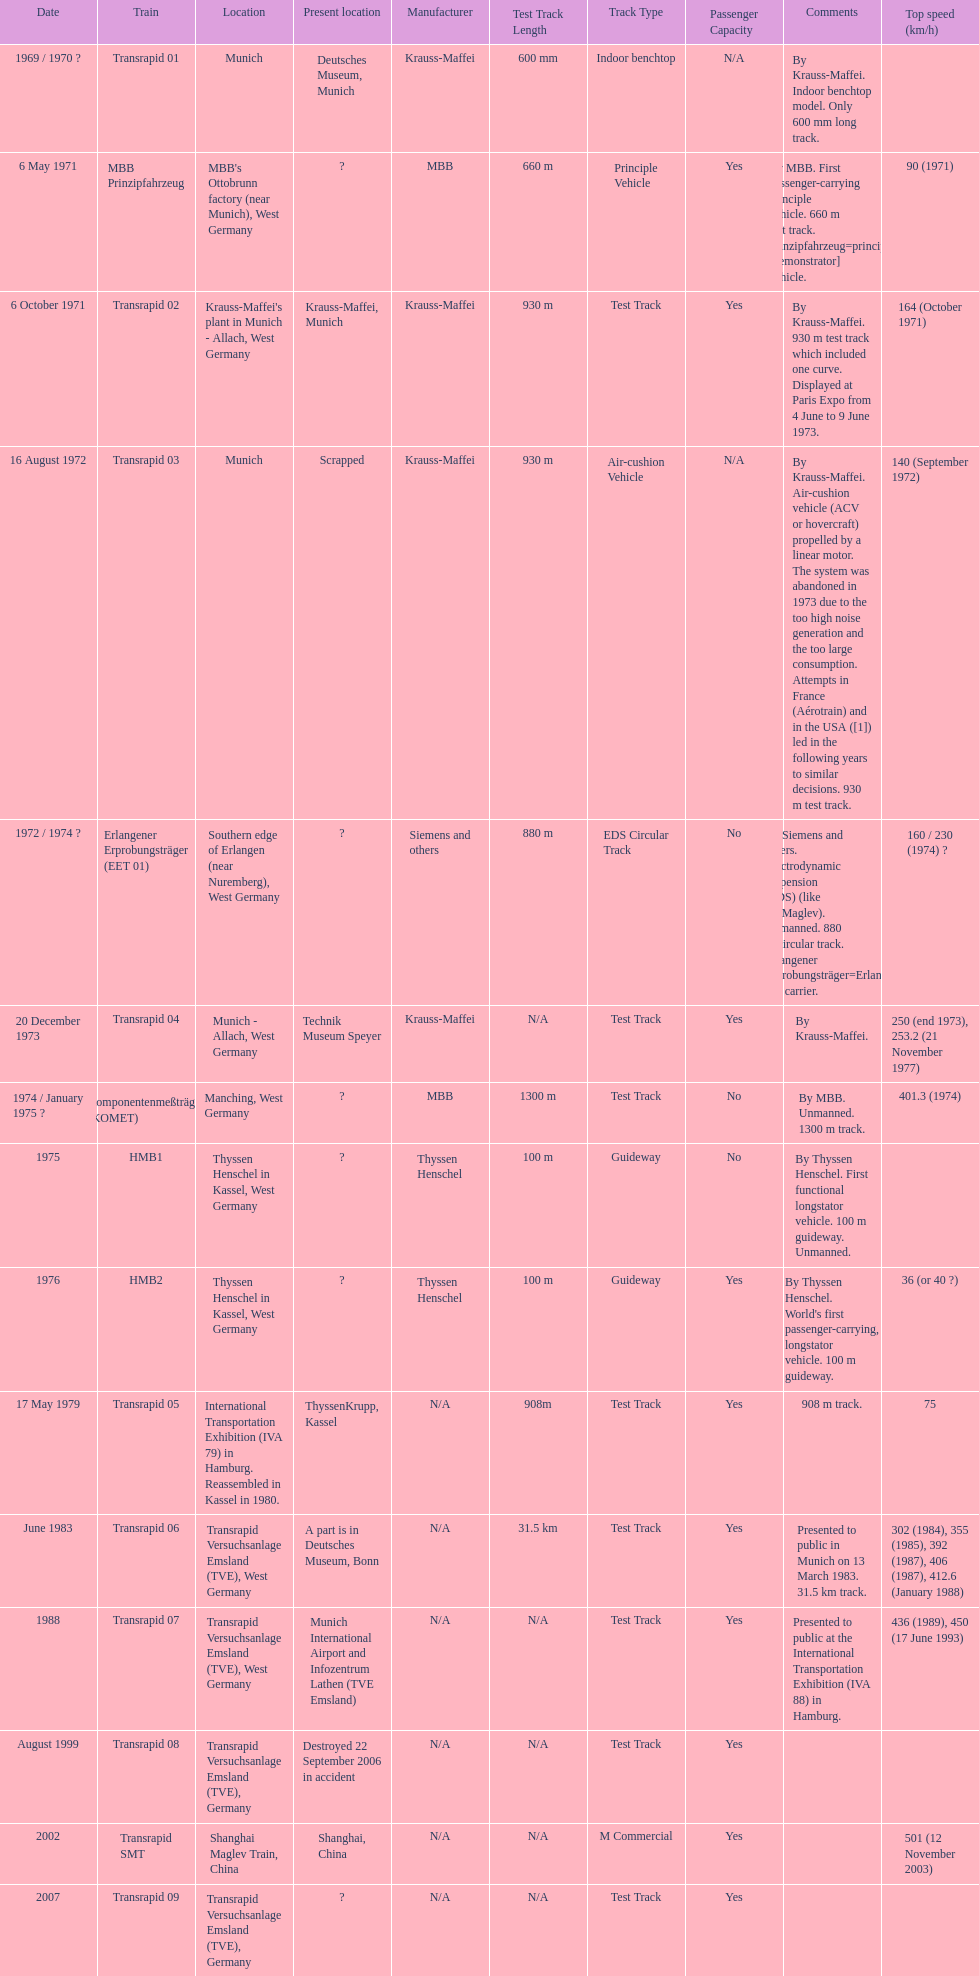What train was established subsequent to the erlangener erprobungsträger? Transrapid 04. 